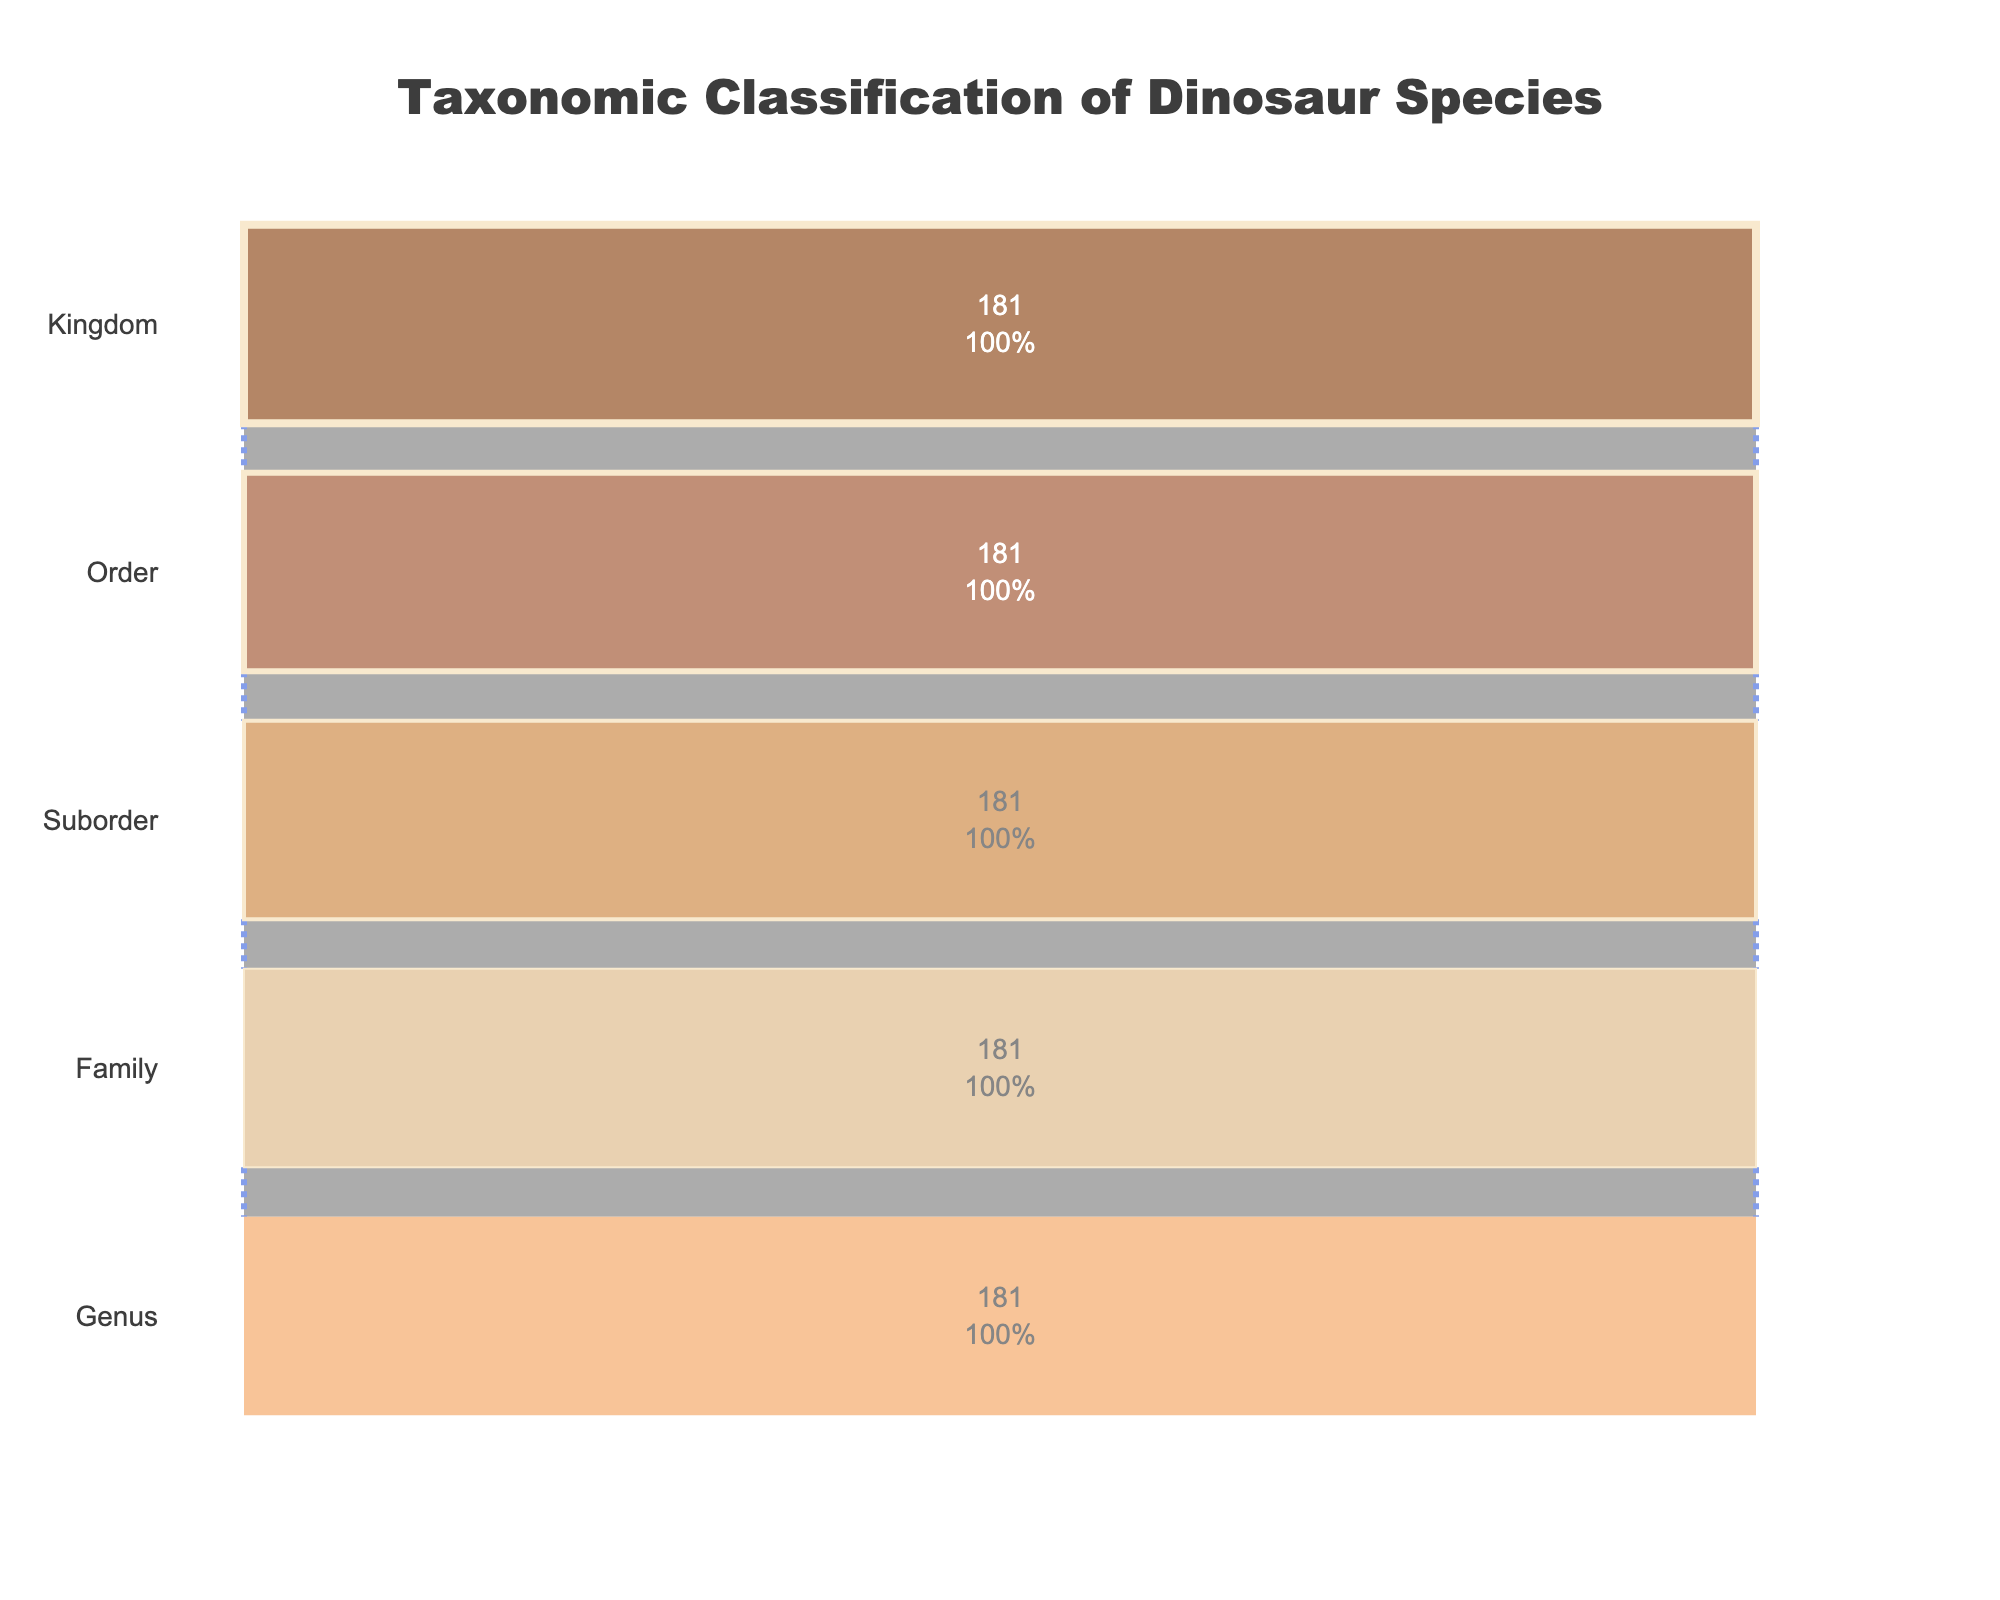What is the title of the figure? The title is prominently displayed at the top of the figure and describes the content of the chart. It reads "Taxonomic Classification of Dinosaur Species".
Answer: Taxonomic Classification of Dinosaur Species How many taxonomic levels are represented in the funnel chart? The funnel chart has different categories labeled on the y-axis from top to bottom: Kingdom, Order, Suborder, Family, and Genus, totaling five levels.
Answer: 5 Which level has the highest value and what is it? The top level, labeled "Kingdom", has the highest value represented by the entire dataset's total count. By summing all counts (42 + 18 + 25 + 31 + 22 + 28 + 15), we get 181.
Answer: Kingdom, 181 Out of all the levels, which one has the lowest value and how much is it? By examining the x-axis values, the "Genus" level has the lowest value, which matches the overall count of dinosaur individuals. The value is 181.
Answer: Genus, 181 What percentage of the total is represented by the "Family" level compared to the "Kingdom" level? The value for the "Family" level is the same as the total value of 181 (there is no decrement across the levels in the data provided). Therefore, the percentage is (181/181) * 100 = 100%.
Answer: 100% Compare the counts between "Order" and "Suborder" levels. Which one has a higher count? Since the dataset represents identical values across levels due to separate categorization but similar sums (181 for each level from the data coding), both levels have an equal count.
Answer: Equal count Between the "Family" and "Genus" levels, does the value change? If so, by how much? According to the data provided, the funnel plot should display the same total values across each level, so there's no numeric change between "Family" (181) and "Genus" (181).
Answer: No change, 0 Explain why the values of "Order", "Suborder", "Family", and "Genus" levels might appear equal in this plot. The equal values at each hierarchical level occur because the counts sum up to the total across all categories for each level. The dataset groups sums by a higher granular level (order to genus), resulting in overlapping total values.
Answer: Counts sum up equally at all levels What color is used to represent the "Order" level in the plot? The funnel chart assigns specific colors to each level. "Order" level is depicted by a distinct brownish shade, which is positioned second from the top.
Answer: Brownish shade 